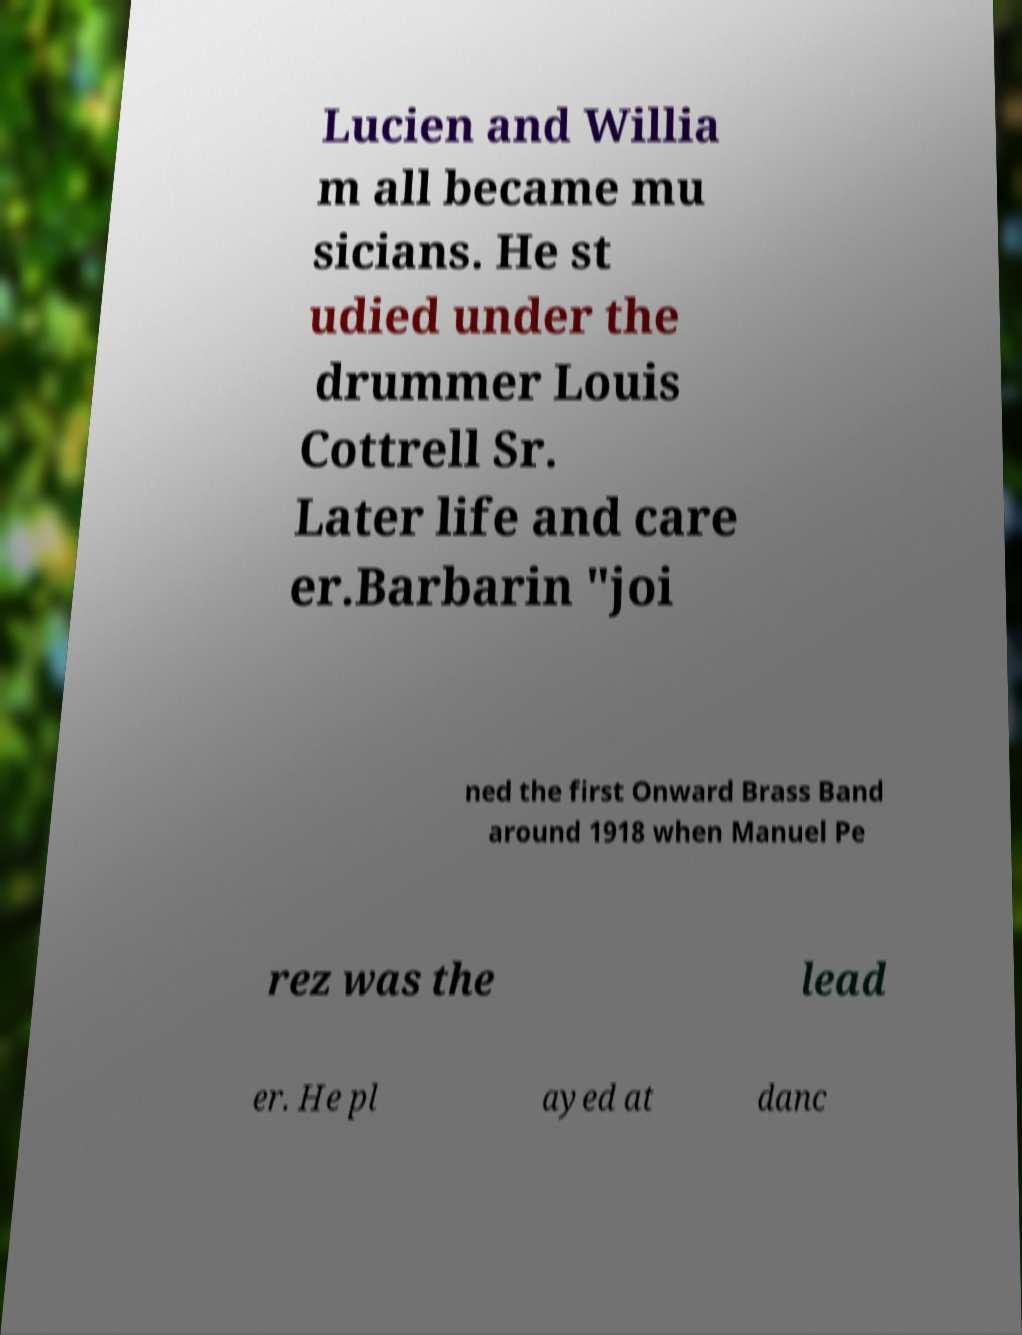Could you extract and type out the text from this image? Lucien and Willia m all became mu sicians. He st udied under the drummer Louis Cottrell Sr. Later life and care er.Barbarin "joi ned the first Onward Brass Band around 1918 when Manuel Pe rez was the lead er. He pl ayed at danc 